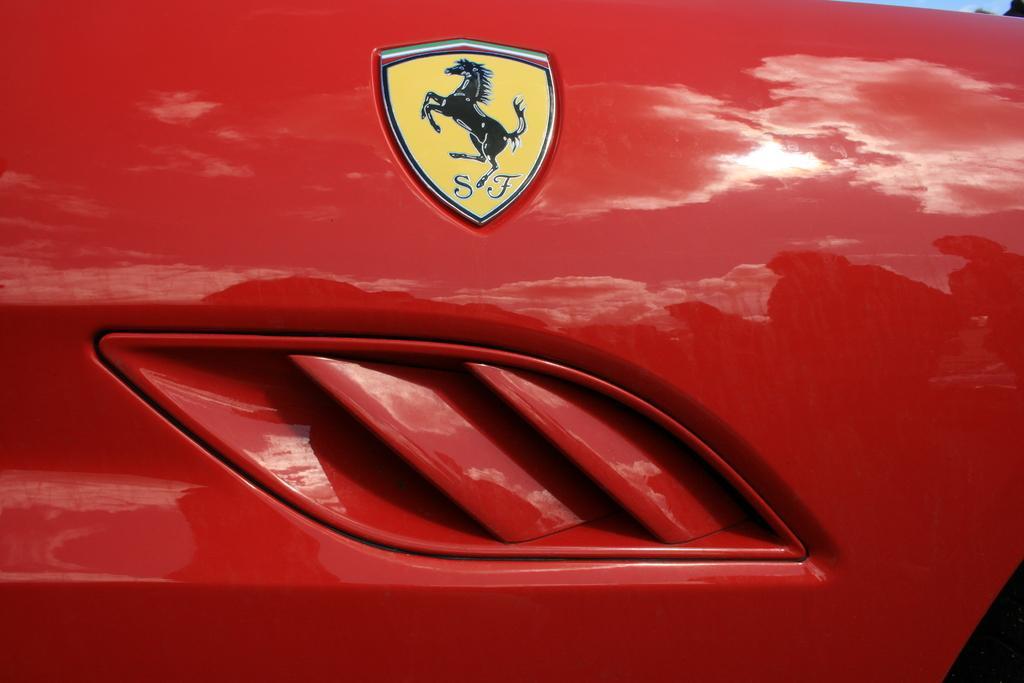How would you summarize this image in a sentence or two? In this picture we can see a logo of a vehicle. 